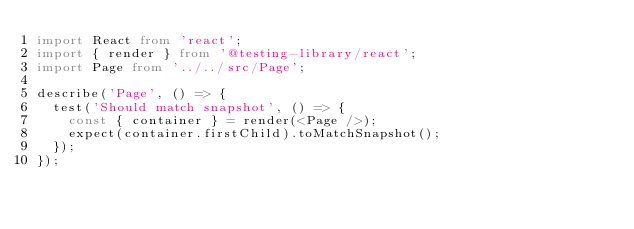Convert code to text. <code><loc_0><loc_0><loc_500><loc_500><_TypeScript_>import React from 'react';
import { render } from '@testing-library/react';
import Page from '../../src/Page';

describe('Page', () => {
  test('Should match snapshot', () => {
    const { container } = render(<Page />);
    expect(container.firstChild).toMatchSnapshot();
  });
});
</code> 